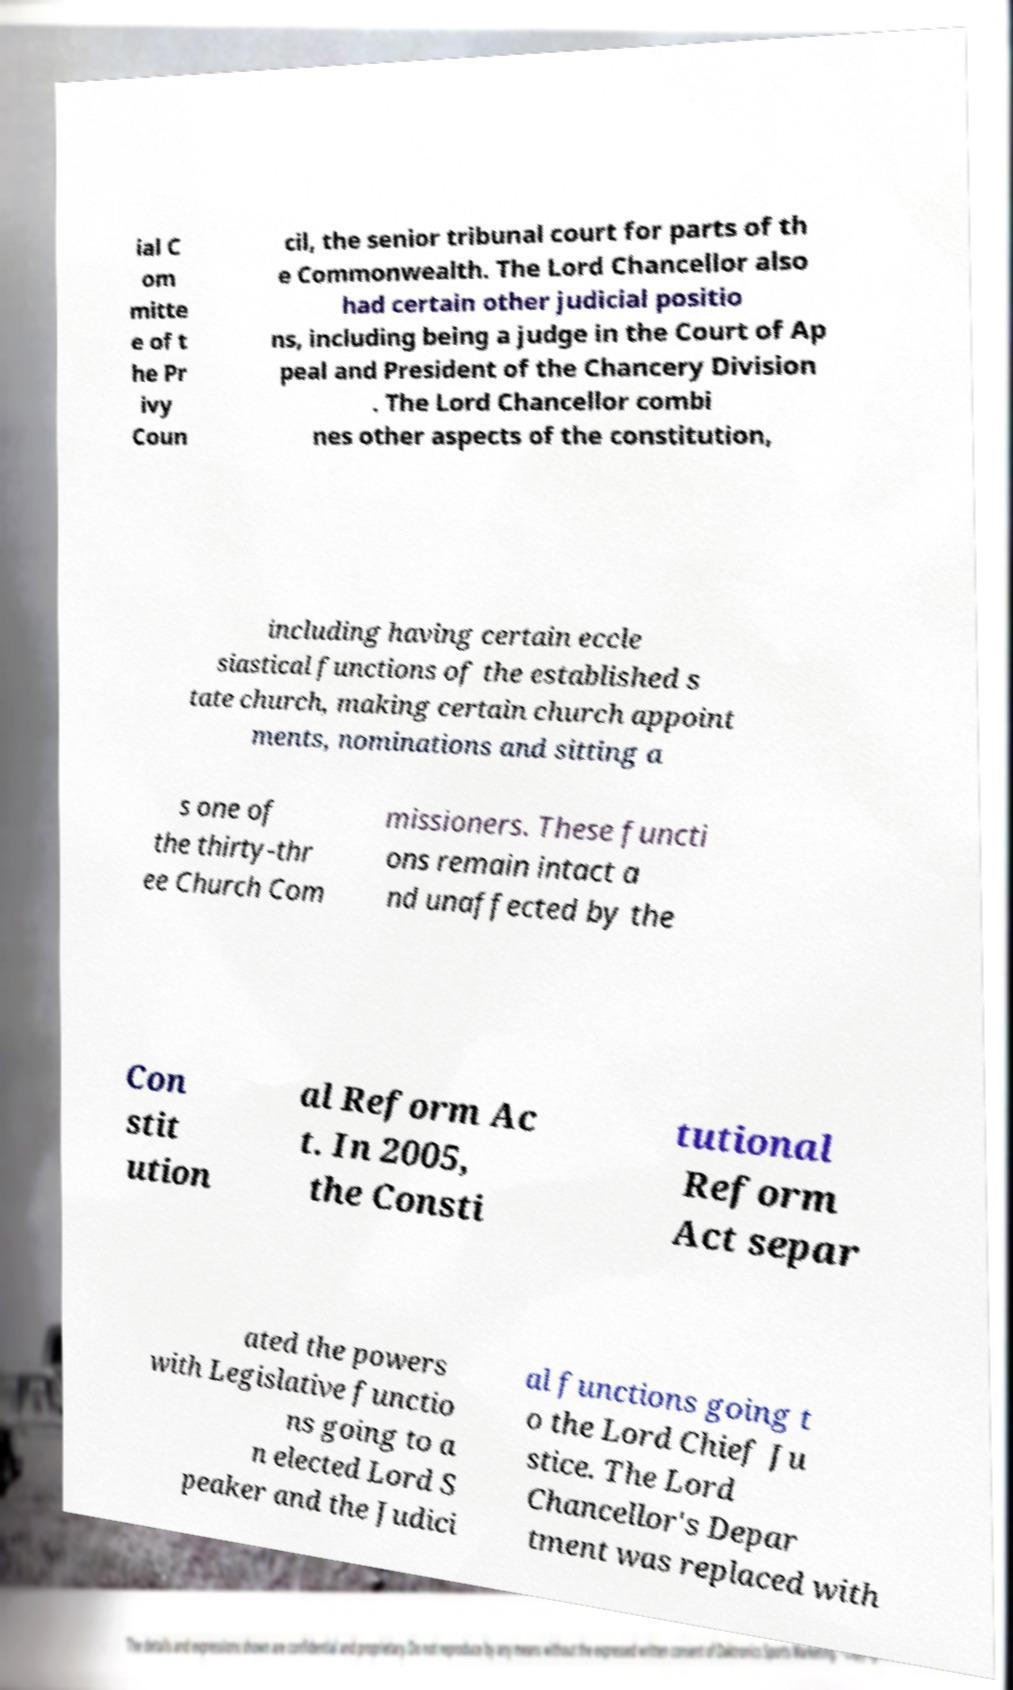What messages or text are displayed in this image? I need them in a readable, typed format. ial C om mitte e of t he Pr ivy Coun cil, the senior tribunal court for parts of th e Commonwealth. The Lord Chancellor also had certain other judicial positio ns, including being a judge in the Court of Ap peal and President of the Chancery Division . The Lord Chancellor combi nes other aspects of the constitution, including having certain eccle siastical functions of the established s tate church, making certain church appoint ments, nominations and sitting a s one of the thirty-thr ee Church Com missioners. These functi ons remain intact a nd unaffected by the Con stit ution al Reform Ac t. In 2005, the Consti tutional Reform Act separ ated the powers with Legislative functio ns going to a n elected Lord S peaker and the Judici al functions going t o the Lord Chief Ju stice. The Lord Chancellor's Depar tment was replaced with 